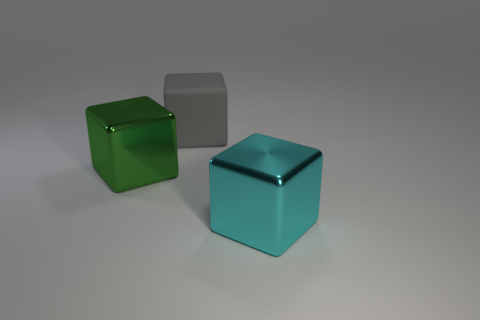Add 1 big cyan metallic blocks. How many objects exist? 4 Add 1 blocks. How many blocks are left? 4 Add 1 brown blocks. How many brown blocks exist? 1 Subtract 0 yellow spheres. How many objects are left? 3 Subtract all tiny purple rubber cubes. Subtract all gray cubes. How many objects are left? 2 